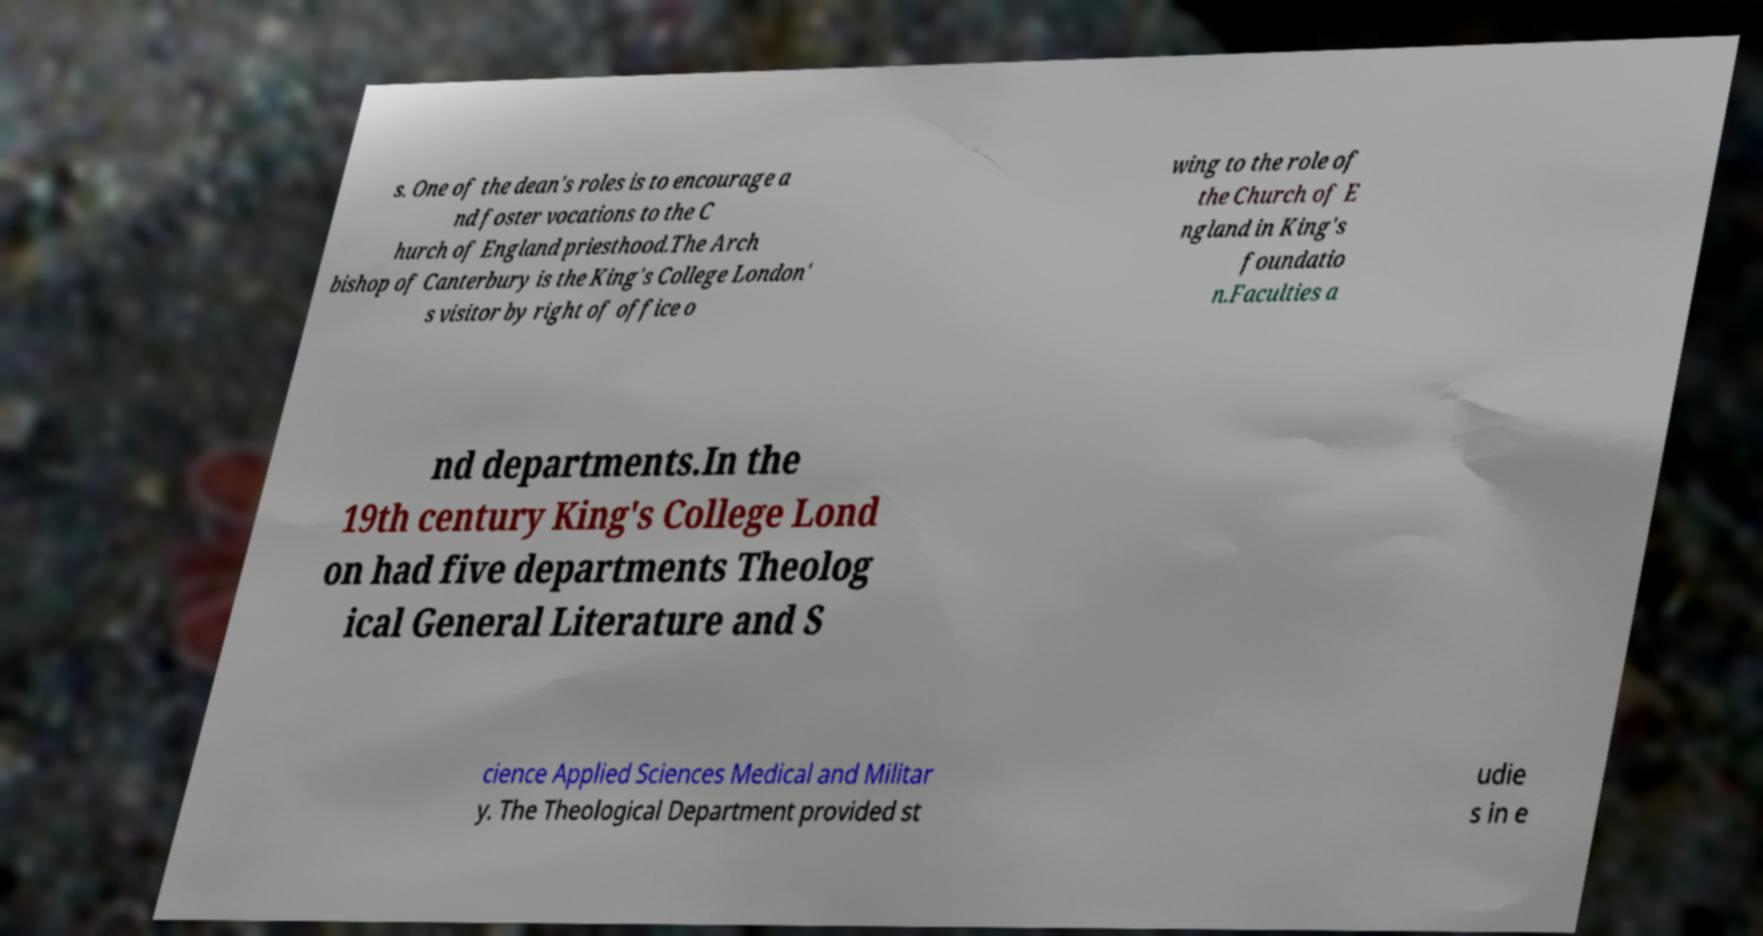Please read and relay the text visible in this image. What does it say? s. One of the dean's roles is to encourage a nd foster vocations to the C hurch of England priesthood.The Arch bishop of Canterbury is the King's College London' s visitor by right of office o wing to the role of the Church of E ngland in King's foundatio n.Faculties a nd departments.In the 19th century King's College Lond on had five departments Theolog ical General Literature and S cience Applied Sciences Medical and Militar y. The Theological Department provided st udie s in e 